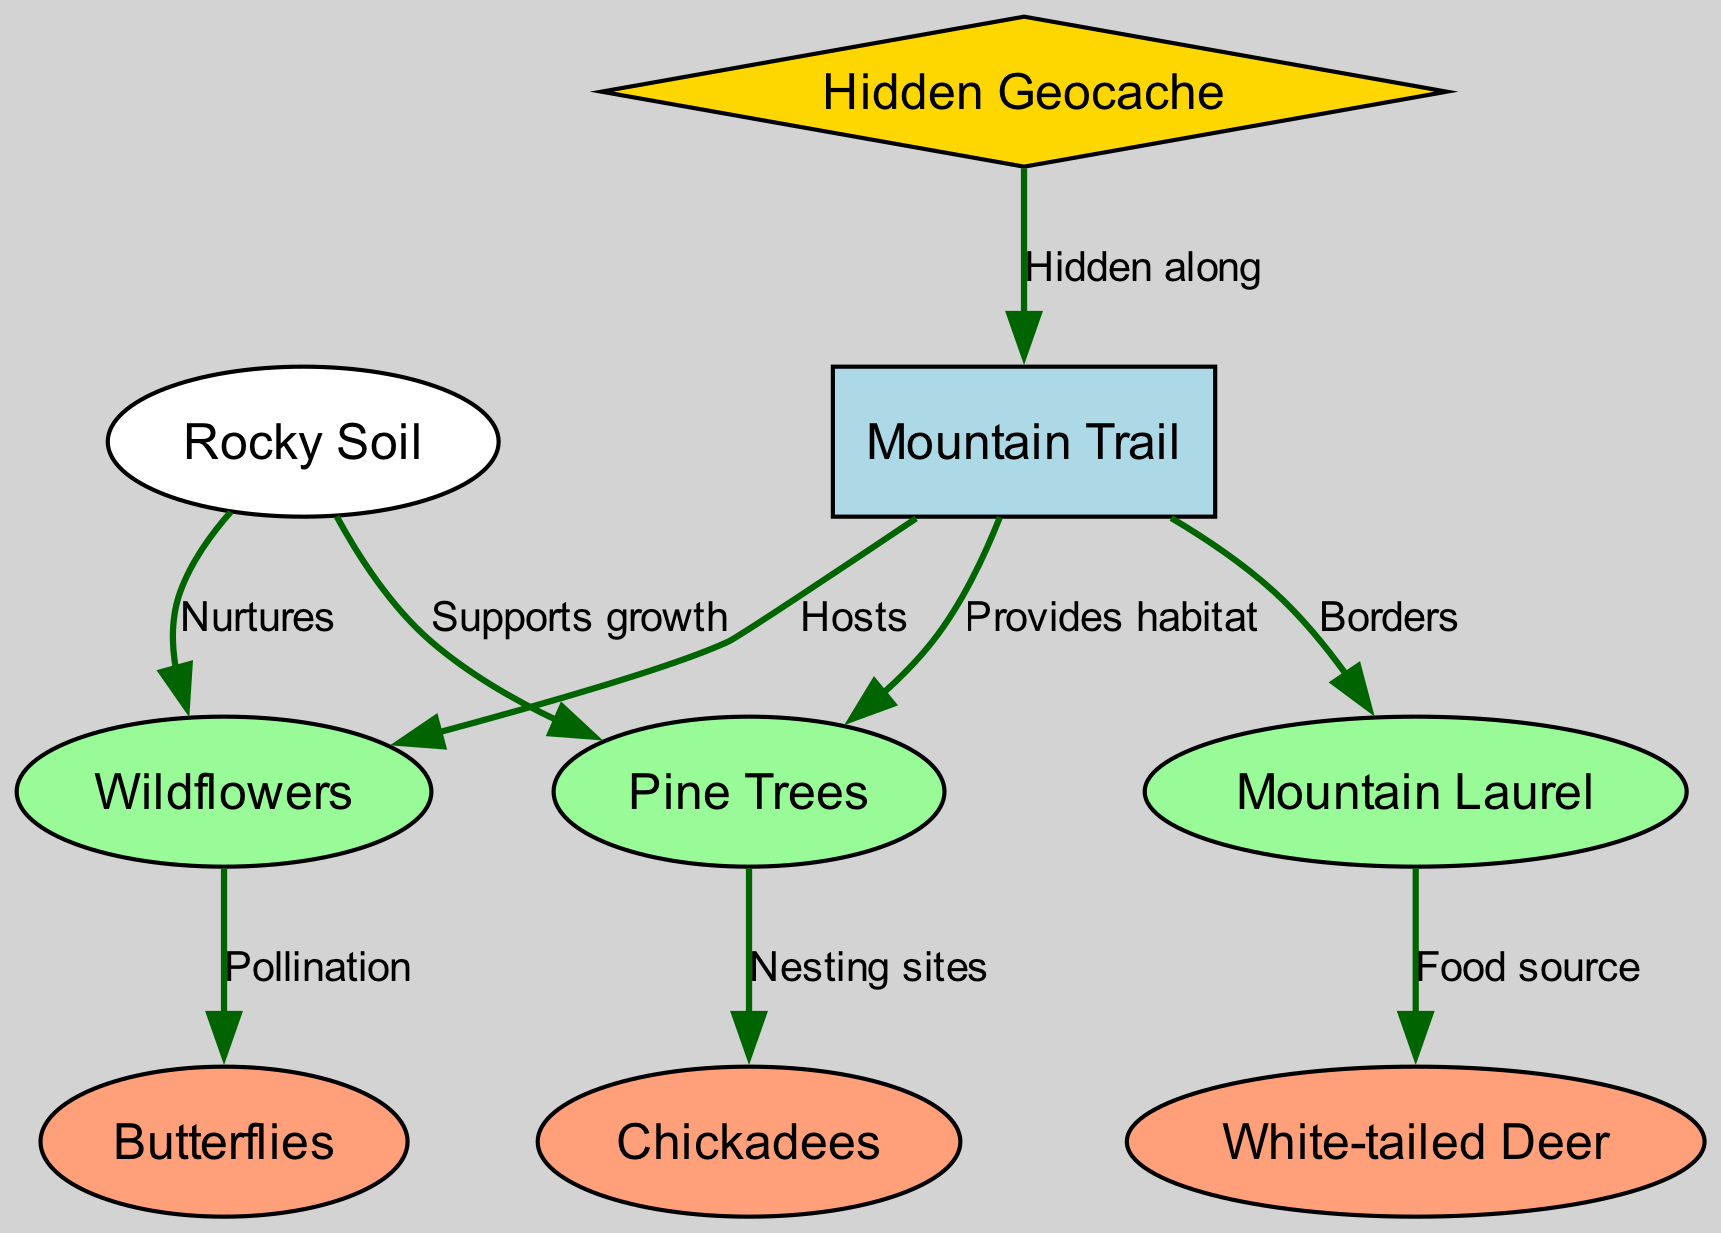What is the main habitat provided by the mountain trail? The diagram indicates that the mountain trail provides habitat for the pine trees. This is represented by the edge labeled "Provides habitat" between the nodes "trail" and "trees."
Answer: habitat How many total nodes are in the diagram? The diagram includes eight nodes, which are the mountain trail, pine trees, mountain laurel, wildflowers, white-tailed deer, chickadees, butterflies, and rocky soil. These nodes are counted individually, leading to a total of eight.
Answer: 8 What animal gets its food source from the mountain laurel? According to the diagram, the white-tailed deer receives its food source from the mountain laurel, as indicated by the edge labeled "Food source" that connects "shrubs" to "deer."
Answer: white-tailed deer What type of ecosystem supports the growth of pine trees? The diagram shows that rocky soil supports the growth of the pine trees. This relationship is depicted by the edge labeled "Supports growth" from the "soil" node to the "trees" node.
Answer: rocky soil Which flora interacts with butterflies in the ecosystem? The diagram illustrates that wildflowers interact with butterflies through pollination. This connection is shown by the edge labeled "Pollination" linking the "flowers" node to the "insects" node.
Answer: wildflowers How many edges are present in the diagram? The diagram contains eight edges, which represent the various relationships between the nodes. Counting each directed relationship gives a total of eight edges.
Answer: 8 What does the hidden geocache signify in relation to the trail? The hidden geocache signifies a point of interest along the mountain trail, as indicated by the edge labeled "Hidden along" that connects the "geocache" node to the "trail" node.
Answer: point of interest What is the function of the soil in relation to flowers? The diagram indicates that the rocky soil nurtures the flowers, which is represented by the edge labeled "Nurtures" from the "soil" node to the "flowers" node.
Answer: nurtures 